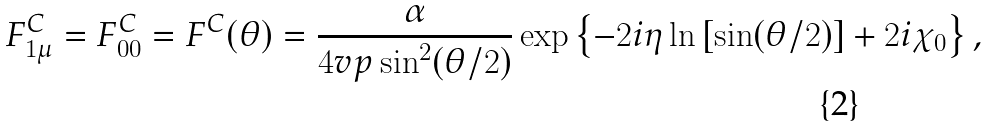<formula> <loc_0><loc_0><loc_500><loc_500>F _ { 1 \mu } ^ { C } = F _ { 0 0 } ^ { C } = F ^ { C } ( \theta ) = \frac { \alpha } { 4 v p \sin ^ { 2 } ( \theta / 2 ) } \exp \left \{ - 2 i \eta \ln \left [ \sin ( \theta / 2 ) \right ] + 2 i \chi _ { 0 } \right \} ,</formula> 